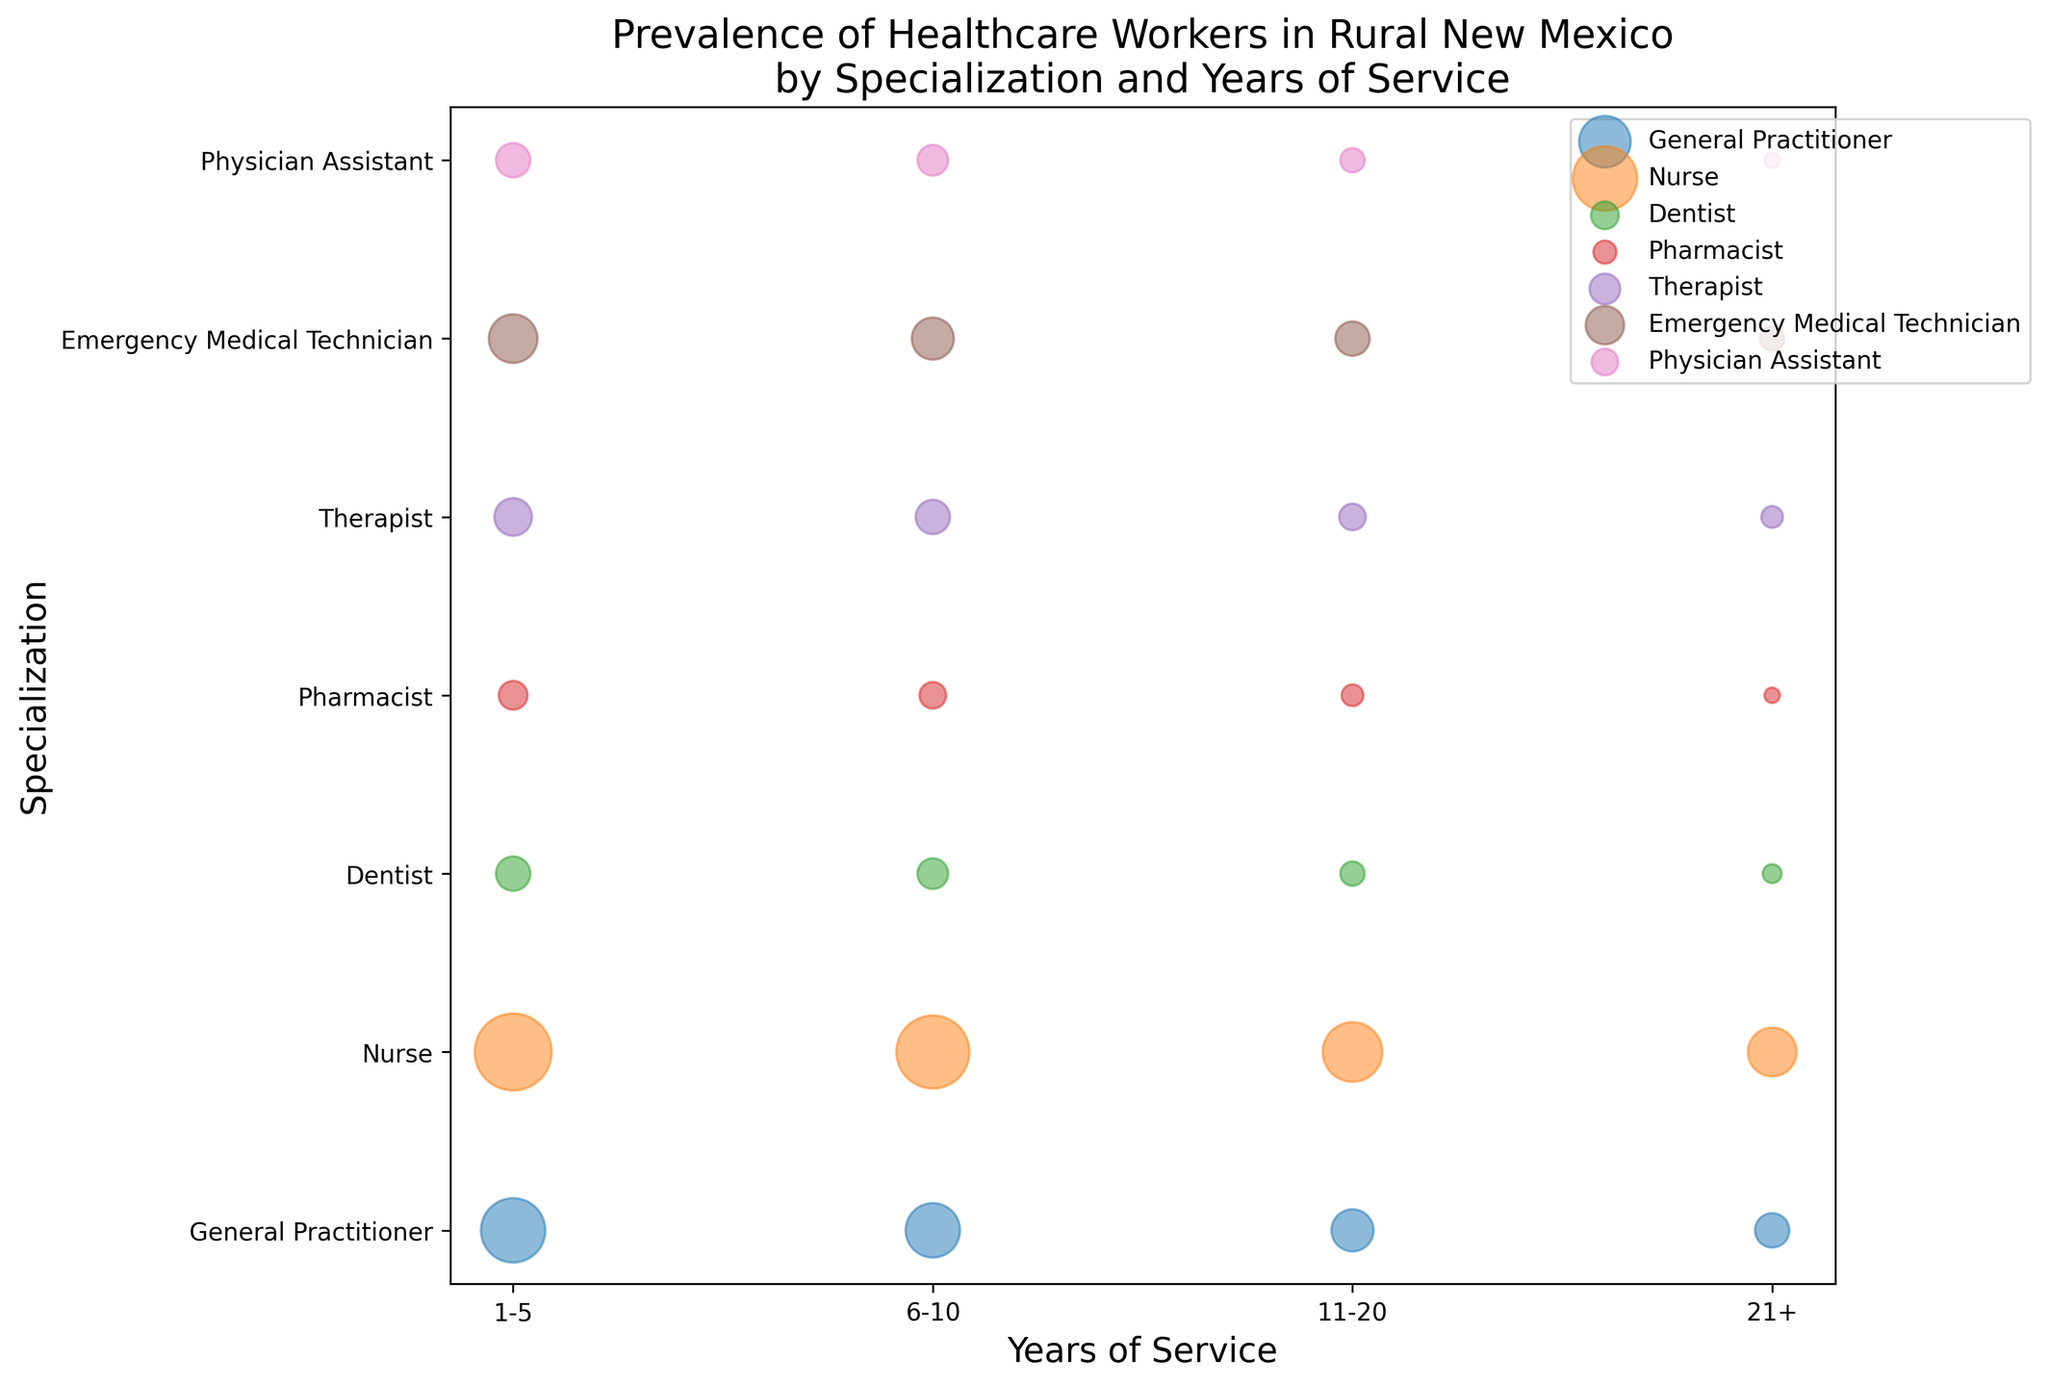What specialization has the highest number of healthcare workers with 1-5 years of service? Look for the largest bubble along the x-axis labeled '1-5' across all specializations. The largest bubble is for Nurses.
Answer: Nurses Which specialization has more healthcare workers with 11-20 years of service, General Practitioner or Emergency Medical Technician? Compare the size of the bubbles for '11-20' years of service for both 'General Practitioner' and 'Emergency Medical Technician'. The bubble for General Practitioner is slightly smaller.
Answer: Emergency Medical Technician What is the difference in the number of healthcare workers between Nurses and Pharmacists for 21+ years of service? Locate the bubbles for 'Nurse' and 'Pharmacist' at '21+' years of service, then calculate the difference. Nurse has a larger bubble for 21+, which represents 20 workers compared to 2 for Pharmacists. The difference is 20 - 2.
Answer: 18 How many more healthcare workers do Nurses have with 6-10 years of service compared to General Practitioners? Check the number of healthcare workers for 'Nurse' and 'General Practitioner' with 6-10 years of service. Nurse has 45, and General Practitioner has 25. The difference is 45 - 25.
Answer: 20 Which specialization has the smallest bubble for 6-10 years of service? Find the smallest bubble along the x-axis labeled '6-10' across all specializations. The smallest bubble corresponds to Pharmacists.
Answer: Pharmacists Do any specializations have the same number of healthcare workers for their maximum years of service? Compare the size of the bubbles for '21+' years of service for each specialization and see if any are equal. Both Pharmacists and Physician Assistants have the smallest bubble of 2 healthcare workers.
Answer: Yes For which years of service do General Practitioners have their highest number of healthcare workers? Find the largest bubble for 'General Practitioners' across all years of service. The largest bubble appears in the '1-5' years of service.
Answer: 1-5 Who has more workers with 11-20 years of service: Nurses or Therapists? Compare the bubble sizes for 'Nurse' and 'Therapist' for '11-20' years of service. Nurse has a larger bubble (30 compared to 6 for Therapists).
Answer: Nurses What is the total number of healthcare workers for Pharmacists in all years of service? Sum the total number of healthcare workers for Pharmacists across all years of service (7 + 6 + 4 + 2). The total number sums up to 19.
Answer: 19 